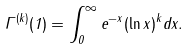Convert formula to latex. <formula><loc_0><loc_0><loc_500><loc_500>\Gamma ^ { ( k ) } ( 1 ) = \int _ { 0 } ^ { \infty } e ^ { - x } ( \ln x ) ^ { k } d x .</formula> 